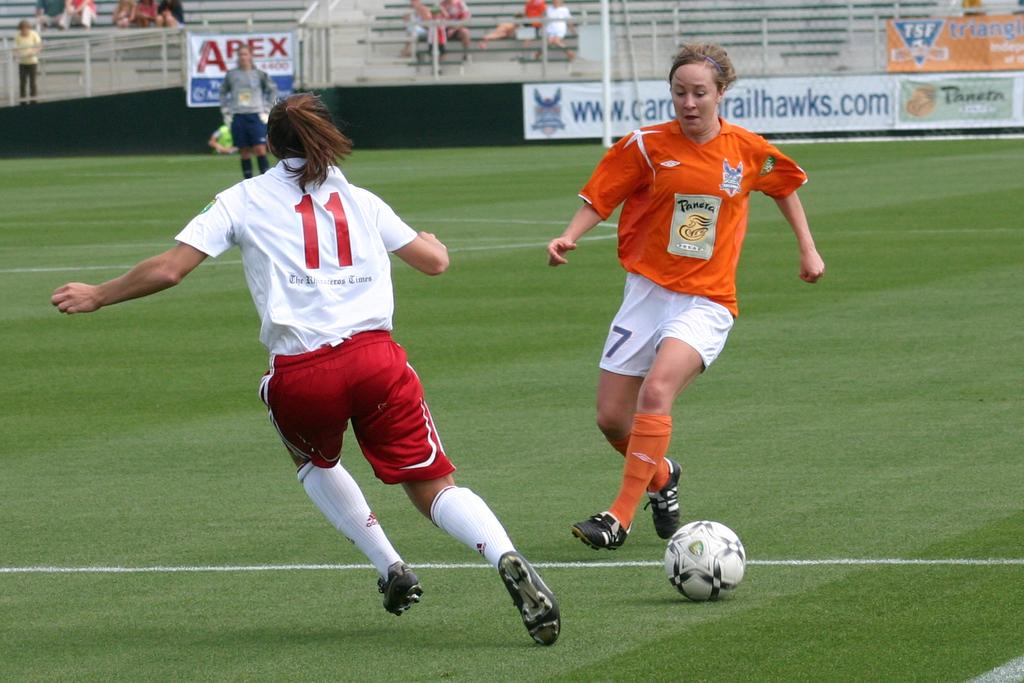<image>
Offer a succinct explanation of the picture presented. Two soccer players, 11 in red and white and 7 on orange and white are both going after the soccer ball on the field. 